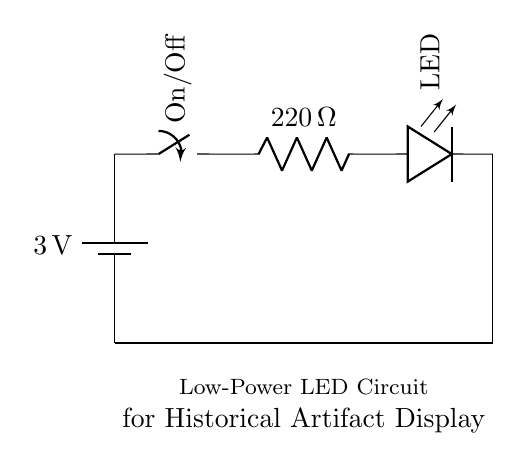What is the voltage of this circuit? The voltage is 3 volts, which is indicated by the battery component. It shows the potential difference provided to power the circuit.
Answer: 3 volts What is the resistance in this circuit? The resistance is 220 ohms, as represented by the resistor component labeled as such in the circuit diagram.
Answer: 220 ohms What is the purpose of the switch in this circuit? The switch controls the flow of electricity; it can either allow or interrupt the current in the circuit according to its position (On/Off).
Answer: Control How does the LED function in this circuit? The LED, or Light Emitting Diode, illuminates when the current flows through it in a successful circuit configuration, allowing it to shine light for viewing artifacts.
Answer: Illuminates What will happen if the battery voltage is increased? Increasing the battery voltage could lead to excessive current through the LED and resistor, potentially damaging the LED due to overheating or exceeding its rated current.
Answer: Damage Why is a resistor used in this low-power LED circuit? The resistor limits the current flowing to the LED to prevent it from drawing too much current, which could cause it to fail; it ensures proper functionality in low-power applications.
Answer: Current limiting 